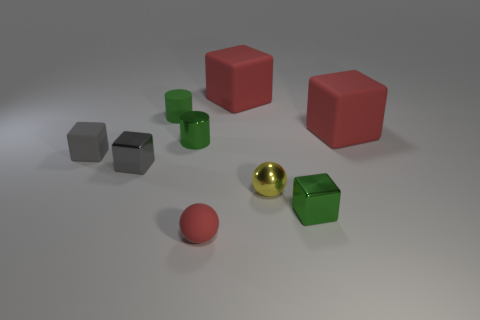Do the yellow ball and the rubber cylinder have the same size?
Your response must be concise. Yes. Is the number of green cylinders on the right side of the yellow ball less than the number of blocks right of the small gray matte cube?
Offer a terse response. Yes. There is a red thing that is to the left of the tiny green cube and behind the tiny yellow ball; what size is it?
Offer a terse response. Large. Are there any tiny objects in front of the shiny object behind the tiny gray cube that is behind the small gray metallic cube?
Offer a very short reply. Yes. Are any tiny yellow shiny things visible?
Your answer should be very brief. Yes. Are there more tiny rubber objects that are on the right side of the green metallic cylinder than small gray shiny objects in front of the yellow metallic object?
Give a very brief answer. Yes. What is the size of the red rubber block that is to the left of the big red rubber thing that is to the right of the green shiny thing in front of the metal ball?
Your answer should be very brief. Large. What is the color of the small sphere that is in front of the tiny green cube?
Your answer should be very brief. Red. Is the number of gray things to the left of the tiny gray shiny block greater than the number of big green blocks?
Provide a succinct answer. Yes. Does the green thing that is on the right side of the small red thing have the same shape as the gray matte object?
Provide a short and direct response. Yes. 